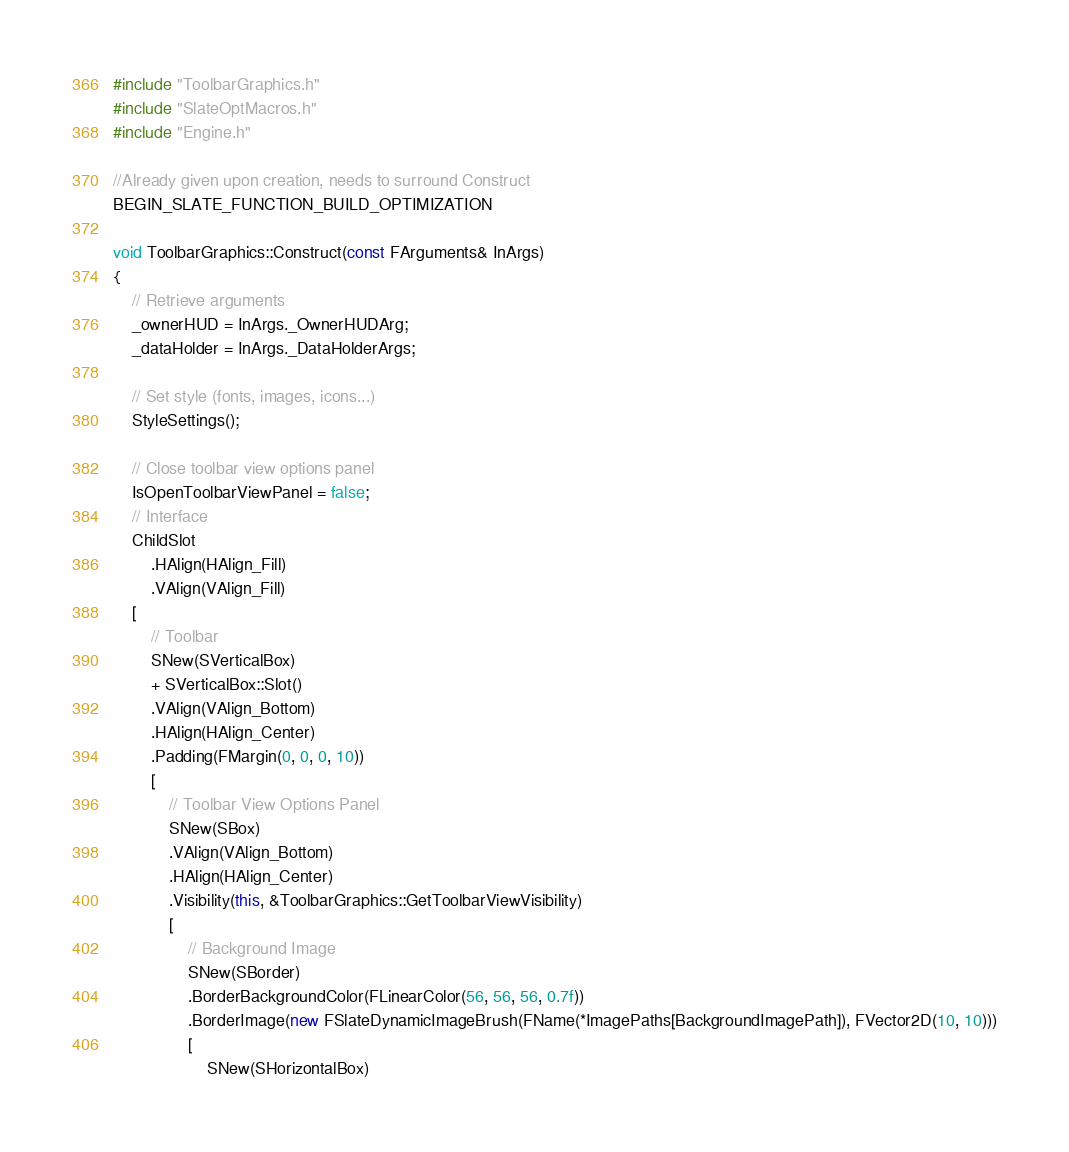<code> <loc_0><loc_0><loc_500><loc_500><_C++_>

#include "ToolbarGraphics.h"
#include "SlateOptMacros.h"
#include "Engine.h"

//Already given upon creation, needs to surround Construct
BEGIN_SLATE_FUNCTION_BUILD_OPTIMIZATION

void ToolbarGraphics::Construct(const FArguments& InArgs)
{
	// Retrieve arguments
	_ownerHUD = InArgs._OwnerHUDArg;
	_dataHolder = InArgs._DataHolderArgs;

	// Set style (fonts, images, icons...)
	StyleSettings();

	// Close toolbar view options panel
	IsOpenToolbarViewPanel = false;
	// Interface
	ChildSlot
		.HAlign(HAlign_Fill)
		.VAlign(VAlign_Fill)
	[
		// Toolbar
		SNew(SVerticalBox)
		+ SVerticalBox::Slot()
		.VAlign(VAlign_Bottom)
		.HAlign(HAlign_Center)
		.Padding(FMargin(0, 0, 0, 10))
		[
			// Toolbar View Options Panel
			SNew(SBox)
			.VAlign(VAlign_Bottom)
			.HAlign(HAlign_Center)
			.Visibility(this, &ToolbarGraphics::GetToolbarViewVisibility)
			[
				// Background Image
				SNew(SBorder)
				.BorderBackgroundColor(FLinearColor(56, 56, 56, 0.7f))
				.BorderImage(new FSlateDynamicImageBrush(FName(*ImagePaths[BackgroundImagePath]), FVector2D(10, 10)))
				[
					SNew(SHorizontalBox)</code> 